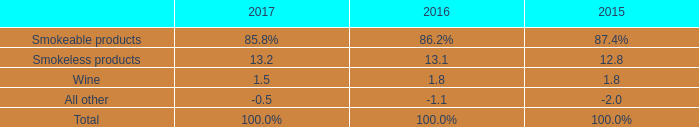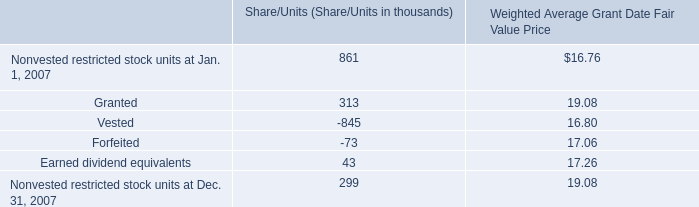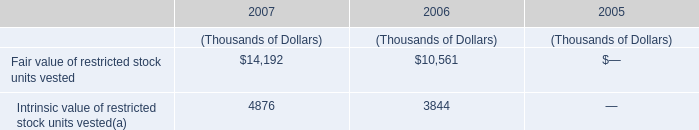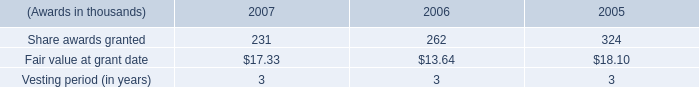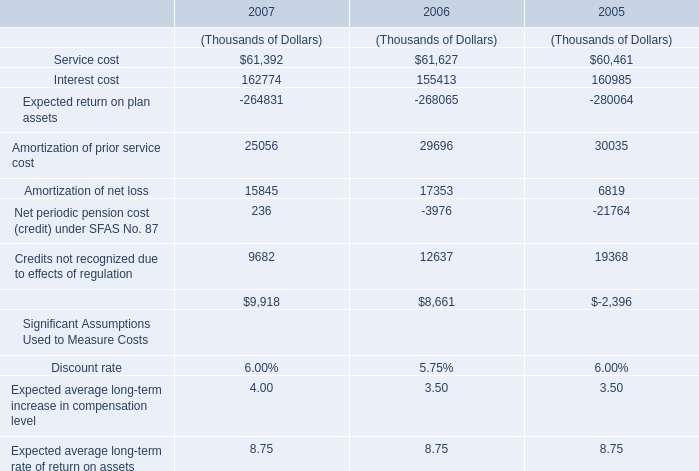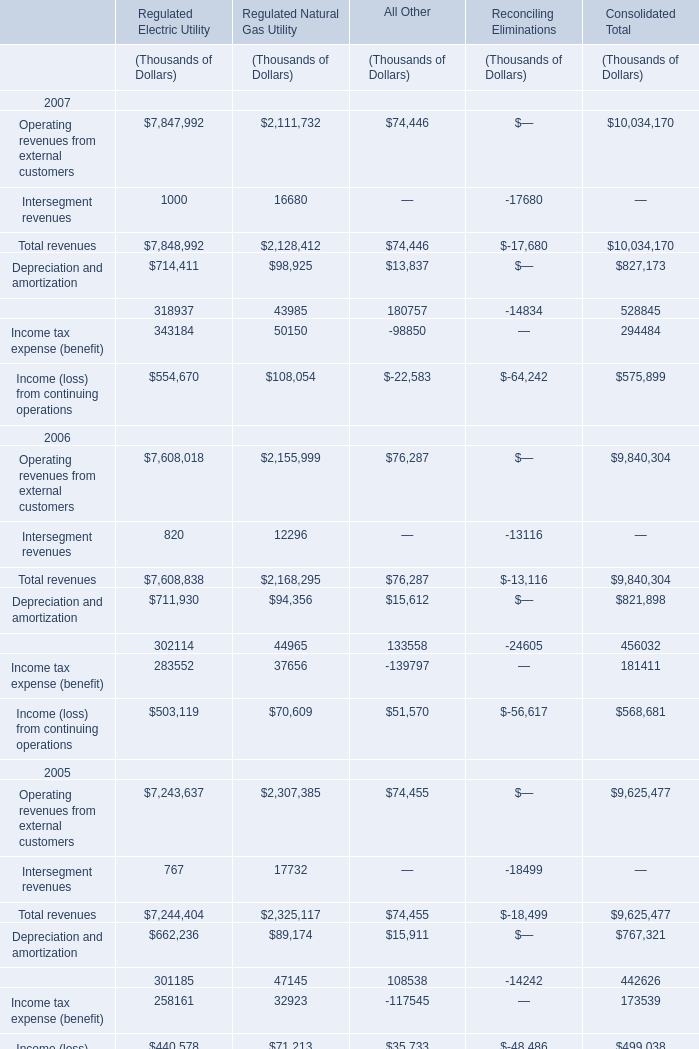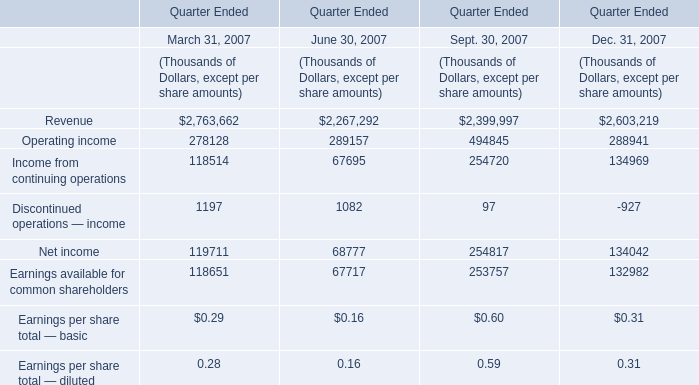In 2006,what is the sum of the Total revenues for Regulated Natural Gas Utility? (in thousand) 
Answer: 2168295. 